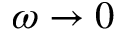<formula> <loc_0><loc_0><loc_500><loc_500>\omega \rightarrow 0</formula> 